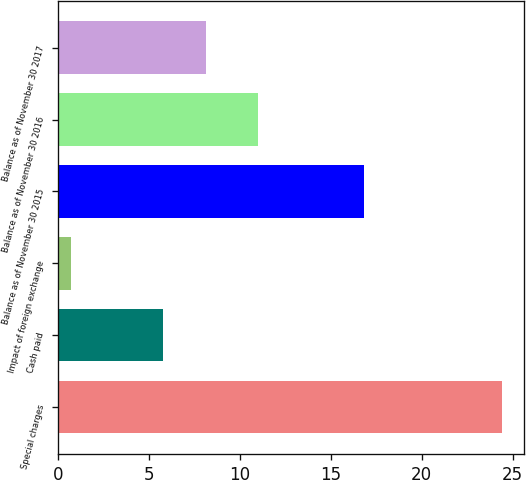Convert chart. <chart><loc_0><loc_0><loc_500><loc_500><bar_chart><fcel>Special charges<fcel>Cash paid<fcel>Impact of foreign exchange<fcel>Balance as of November 30 2015<fcel>Balance as of November 30 2016<fcel>Balance as of November 30 2017<nl><fcel>24.4<fcel>5.8<fcel>0.7<fcel>16.8<fcel>11<fcel>8.17<nl></chart> 